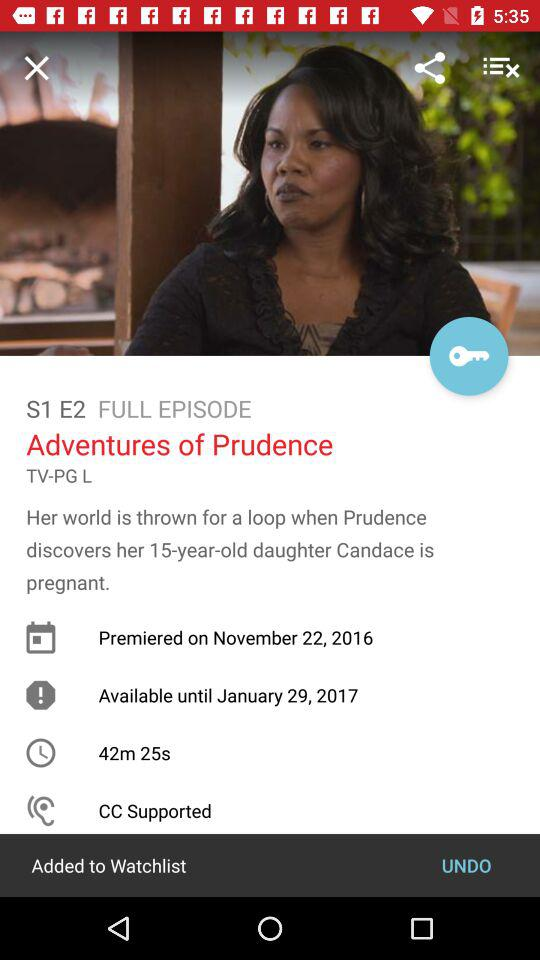What is the time duration? The time duration is 42 minutes 25 seconds. 